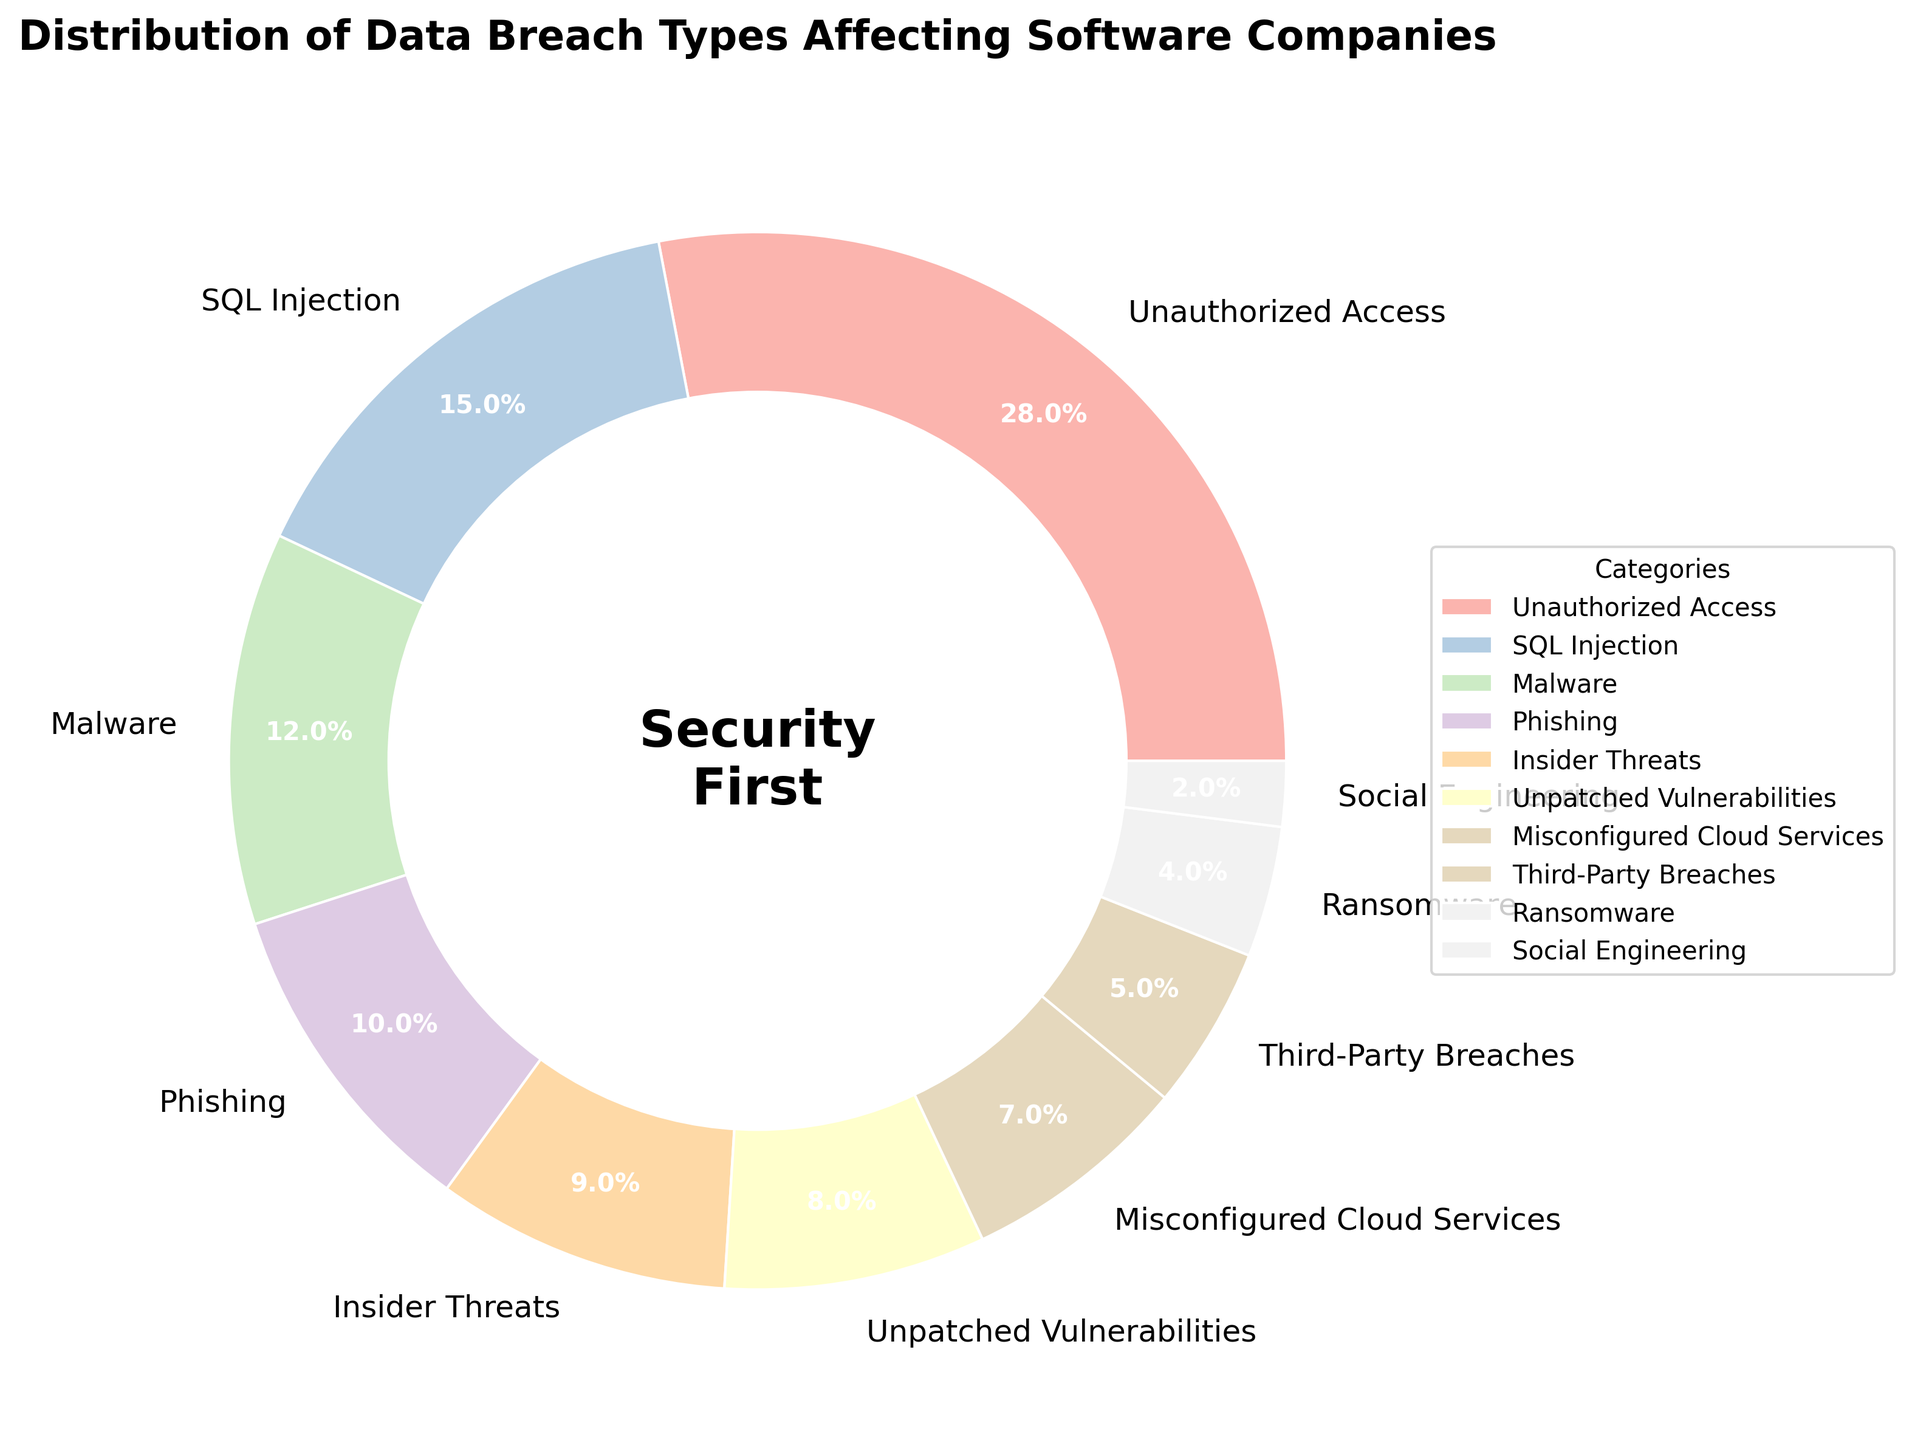What percentage of data breach types are due to Insider Threats and Misconfigured Cloud Services combined? First, note the percentages of Insider Threats (9%) and Misconfigured Cloud Services (7%). Then, sum these percentages: 9% + 7% = 16%.
Answer: 16% Which data breach type has the smallest percentage, and what is it? Identify the slice with the smallest percentage. From the data, this is Social Engineering with 2%.
Answer: Social Engineering, 2% Compare Unauthorized Access and SQL Injection; which is higher and by how much? Unauthorized Access is 28%, and SQL Injection is 15%. Subtract the smaller percentage from the larger one: 28% - 15% = 13%.
Answer: Unauthorized Access is higher by 13% What is the total percentage of data breach types caused by external actors (Unauthorized Access, SQL Injection, Malware, Phishing)? Add the percentages of Unauthorized Access (28%), SQL Injection (15%), Malware (12%), and Phishing (10%): 28 + 15 + 12 + 10 = 65%.
Answer: 65% What percentage of data breaches types are due to Third-Party Breaches and Ransomware together? Add the percentages of Third-Party Breaches (5%) and Ransomware (4%): 5% + 4% = 9%.
Answer: 9% Which category is represented by the largest slice, and what is its percentage? Identify the largest slice in the pie chart, which is Unauthorized Access at 28%.
Answer: Unauthorized Access, 28% How does Phishing compare to Ransomware in terms of percentage? Phishing has a percentage of 10%, whereas Ransomware has 4%. Subtract the smaller from the larger: 10% - 4% = 6%.
Answer: Phishing is higher by 6% What are the second and third most common data breach types? After identifying all percentages, the second most common is SQL Injection (15%), and the third most common is Malware (12%).
Answer: SQL Injection and Malware If you were to remove the percentages of Unauthorized Access and SQL Injection, what percentage of the remaining data breaches would you have? Subtract the summed percentage of Unauthorized Access (28%) and SQL Injection (15%) from 100%: 100% - (28% + 15%) = 100% - 43% = 57%.
Answer: 57% What is the combined percentage of breaches from Unpatched Vulnerabilities and Misconfigured Cloud Services? Add the percentages of Unpatched Vulnerabilities (8%) and Misconfigured Cloud Services (7%): 8% + 7% = 15%.
Answer: 15% 